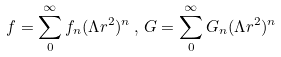<formula> <loc_0><loc_0><loc_500><loc_500>f = \sum _ { 0 } ^ { \infty } f _ { n } ( \Lambda r ^ { 2 } ) ^ { n } \, , \, G = \sum _ { 0 } ^ { \infty } G _ { n } ( \Lambda r ^ { 2 } ) ^ { n }</formula> 